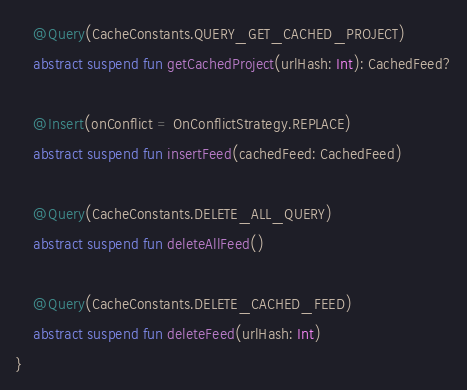<code> <loc_0><loc_0><loc_500><loc_500><_Kotlin_>    @Query(CacheConstants.QUERY_GET_CACHED_PROJECT)
    abstract suspend fun getCachedProject(urlHash: Int): CachedFeed?

    @Insert(onConflict = OnConflictStrategy.REPLACE)
    abstract suspend fun insertFeed(cachedFeed: CachedFeed)

    @Query(CacheConstants.DELETE_ALL_QUERY)
    abstract suspend fun deleteAllFeed()

    @Query(CacheConstants.DELETE_CACHED_FEED)
    abstract suspend fun deleteFeed(urlHash: Int)
}</code> 